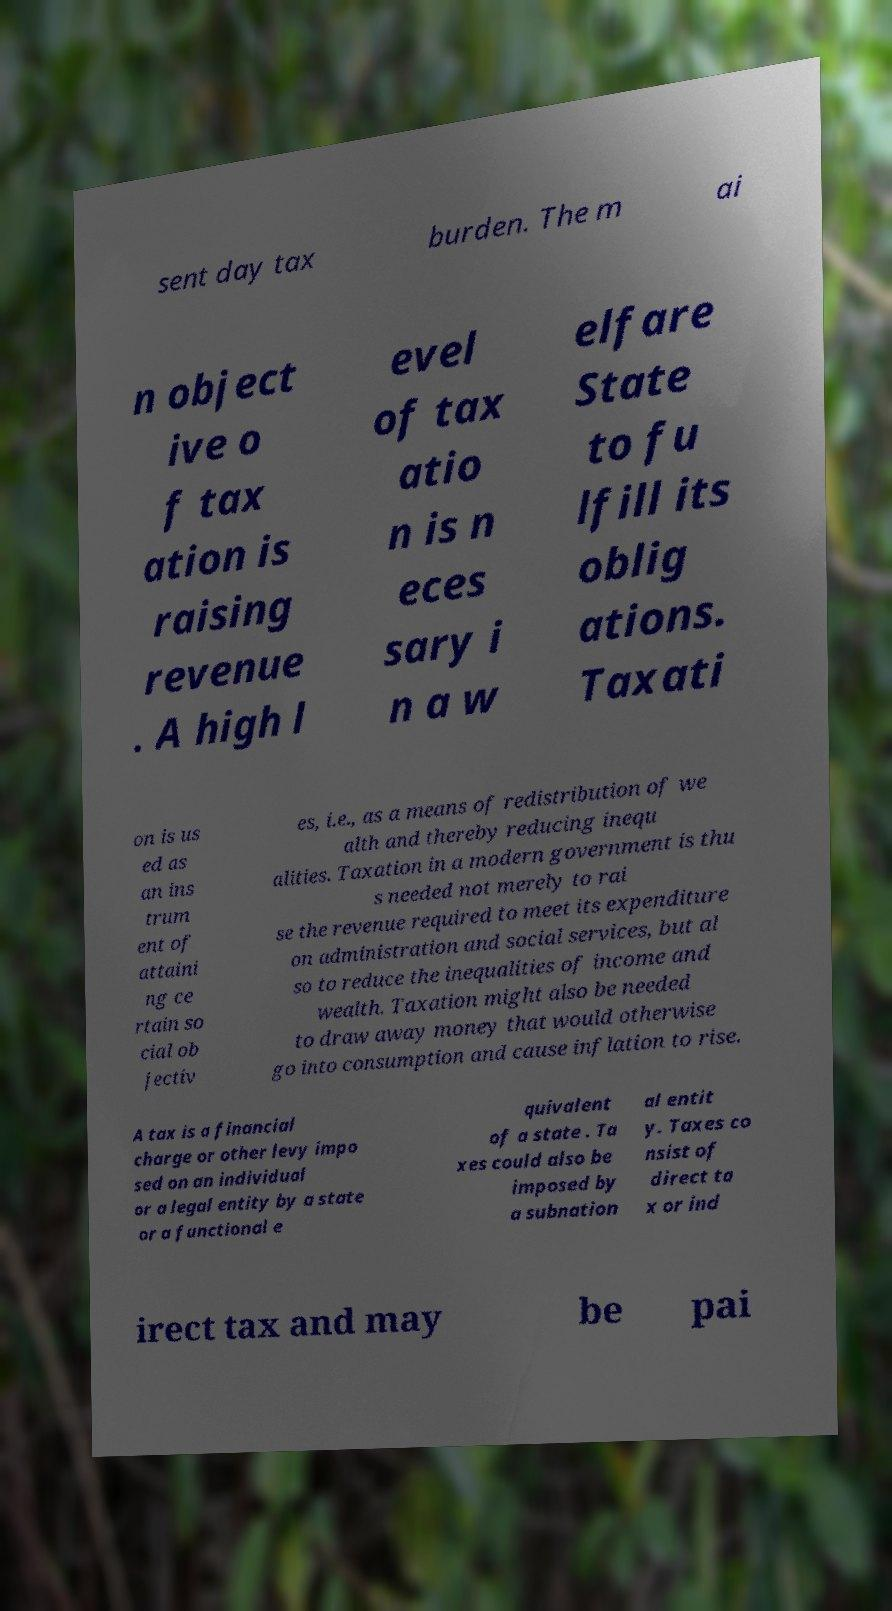Please identify and transcribe the text found in this image. sent day tax burden. The m ai n object ive o f tax ation is raising revenue . A high l evel of tax atio n is n eces sary i n a w elfare State to fu lfill its oblig ations. Taxati on is us ed as an ins trum ent of attaini ng ce rtain so cial ob jectiv es, i.e., as a means of redistribution of we alth and thereby reducing inequ alities. Taxation in a modern government is thu s needed not merely to rai se the revenue required to meet its expenditure on administration and social services, but al so to reduce the inequalities of income and wealth. Taxation might also be needed to draw away money that would otherwise go into consumption and cause inflation to rise. A tax is a financial charge or other levy impo sed on an individual or a legal entity by a state or a functional e quivalent of a state . Ta xes could also be imposed by a subnation al entit y. Taxes co nsist of direct ta x or ind irect tax and may be pai 